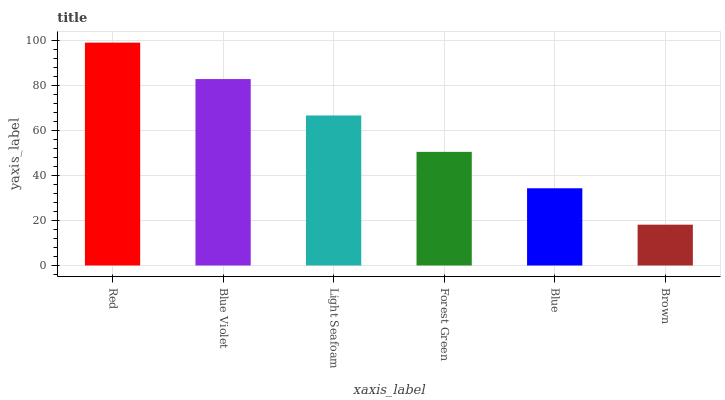Is Brown the minimum?
Answer yes or no. Yes. Is Red the maximum?
Answer yes or no. Yes. Is Blue Violet the minimum?
Answer yes or no. No. Is Blue Violet the maximum?
Answer yes or no. No. Is Red greater than Blue Violet?
Answer yes or no. Yes. Is Blue Violet less than Red?
Answer yes or no. Yes. Is Blue Violet greater than Red?
Answer yes or no. No. Is Red less than Blue Violet?
Answer yes or no. No. Is Light Seafoam the high median?
Answer yes or no. Yes. Is Forest Green the low median?
Answer yes or no. Yes. Is Blue Violet the high median?
Answer yes or no. No. Is Light Seafoam the low median?
Answer yes or no. No. 